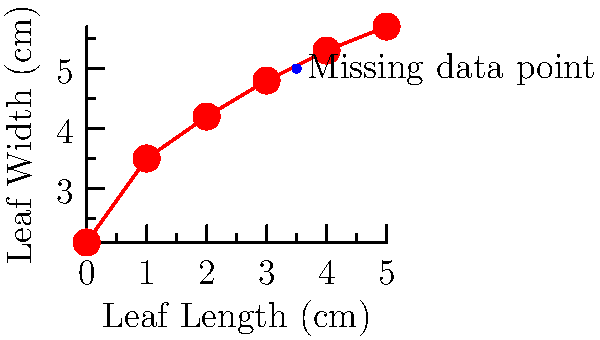In a taxonomic study of leaf shapes, you have collected data on leaf length and width for a particular species. The data points are plotted in the graph above, with leaf length on the x-axis and leaf width on the y-axis. You suspect that the relationship between leaf length and width can be modeled by a quadratic polynomial. However, there is a missing data point at leaf length 3.5 cm. Using polynomial interpolation, estimate the leaf width at 3.5 cm to the nearest 0.1 cm. To estimate the missing data point using polynomial interpolation, we'll follow these steps:

1) Given that we suspect a quadratic relationship, we'll use the quadratic polynomial form:
   $f(x) = ax^2 + bx + c$

2) We need three points to determine the coefficients a, b, and c. Let's choose:
   (0, 2.1), (2, 4.2), and (5, 5.7)

3) Substituting these points into the quadratic equation:
   2.1 = c
   4.2 = 4a + 2b + c
   5.7 = 25a + 5b + c

4) Subtracting the first equation from the second and third:
   2.1 = 4a + 2b
   3.6 = 25a + 5b

5) Multiplying the first equation by 5 and the second by 2:
   10.5 = 20a + 10b
   7.2 = 50a + 10b

6) Subtracting these equations:
   3.3 = -30a
   a = -0.11

7) Substituting this back into 2.1 = 4a + 2b:
   2.1 = 4(-0.11) + 2b
   2.1 = -0.44 + 2b
   2.54 = 2b
   b = 1.27

8) We can find c from the original equation:
   c = 2.1

9) Our quadratic polynomial is:
   $f(x) = -0.11x^2 + 1.27x + 2.1$

10) To find the leaf width at length 3.5 cm, we evaluate f(3.5):
    $f(3.5) = -0.11(3.5)^2 + 1.27(3.5) + 2.1$
    $= -0.11(12.25) + 4.445 + 2.1$
    $= -1.3475 + 4.445 + 2.1$
    $= 5.1975$

11) Rounding to the nearest 0.1 cm:
    5.1975 ≈ 5.2 cm
Answer: 5.2 cm 